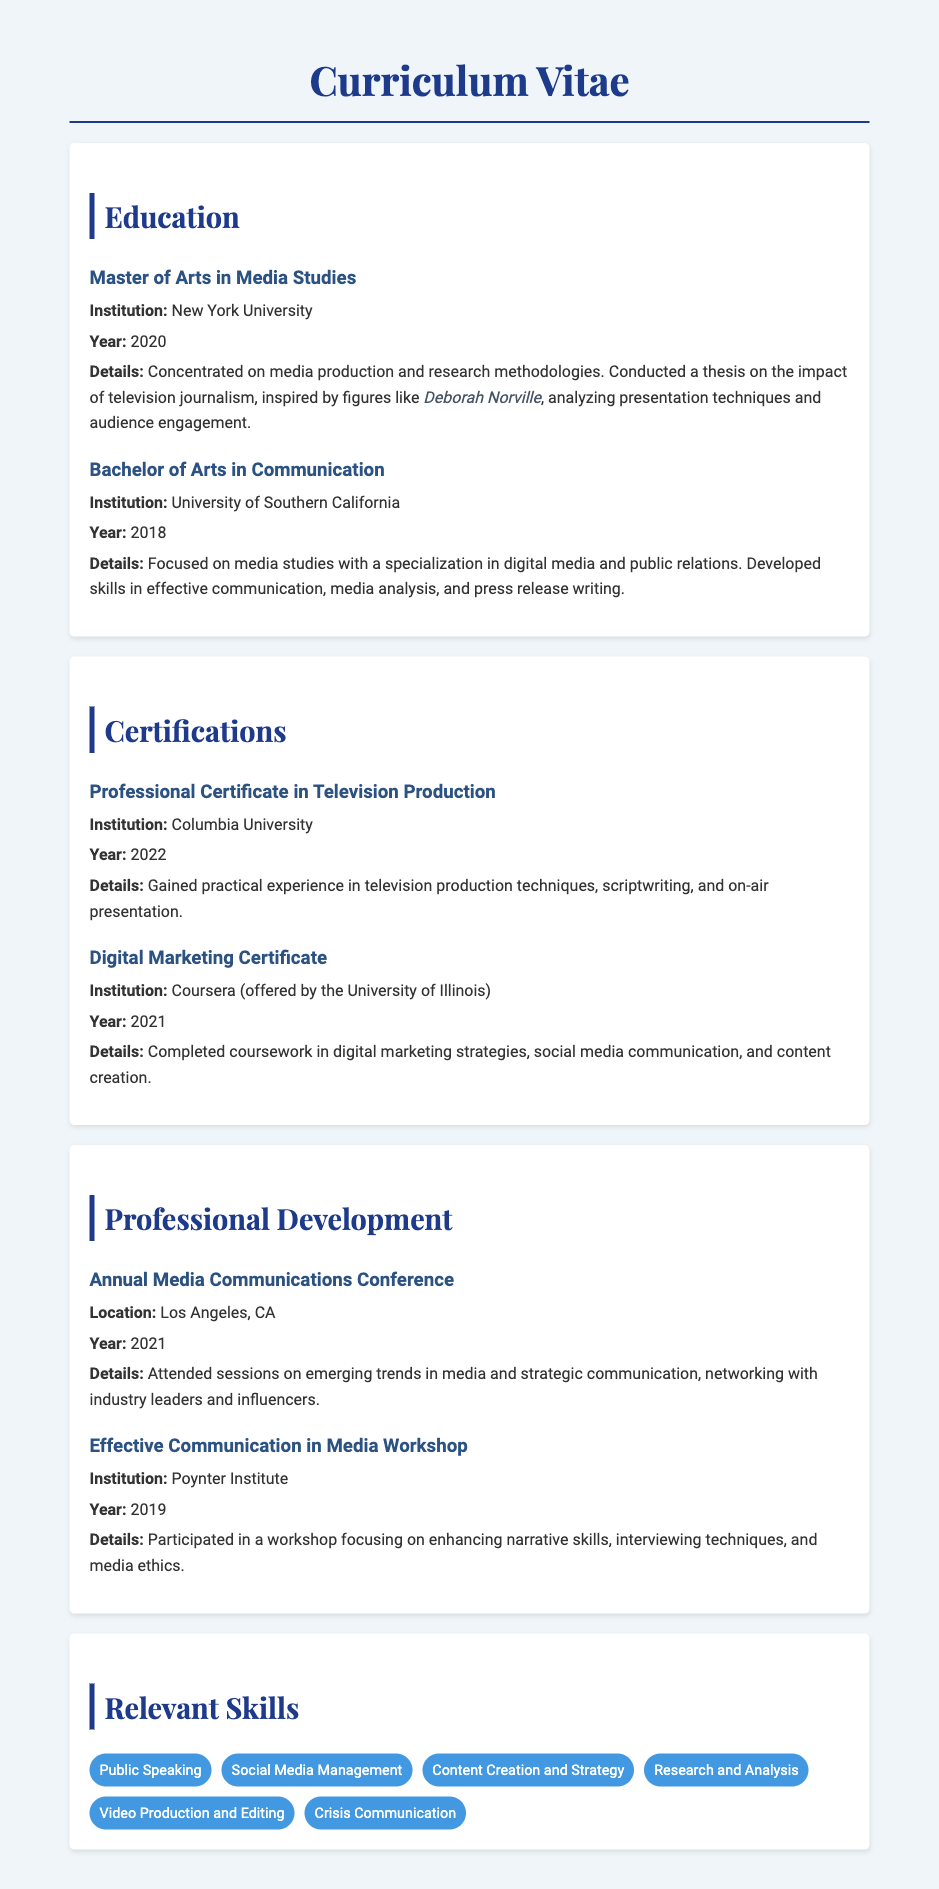What degree was obtained? The document specifies the highest degree achieved, which is clearly stated under the education section.
Answer: Master of Arts in Media Studies What year did the individual graduate from the University of Southern California? The document includes specific graduation years for each educational entry listed.
Answer: 2018 What was the thesis topic in the Master of Arts program? The document provides details about the thesis conducted during the Master’s program, indicating its focus area.
Answer: Impact of television journalism Which institution awarded the Professional Certificate in Television Production? The document names various institutions associated with certifications and degrees.
Answer: Columbia University What skills are listed as relevant skills? The document outlines specific skills that are emphasized in the relevant skills section.
Answer: Public Speaking, Social Media Management, Content Creation and Strategy, Research and Analysis, Video Production and Editing, Crisis Communication How many years passed between obtaining a Bachelor's and a Master's degree? The question requires a calculation based on graduation years provided for each degree, highlighting the time lapse between programs.
Answer: 2 years What certification was acquired in 2021? The document lists all certifications along with their corresponding years, making it easy to identify the one obtained that year.
Answer: Digital Marketing Certificate What was the focus of the Effective Communication in Media Workshop? The document provides specifics about the purpose and content of workshops attended.
Answer: Enhancing narrative skills, interviewing techniques, and media ethics 